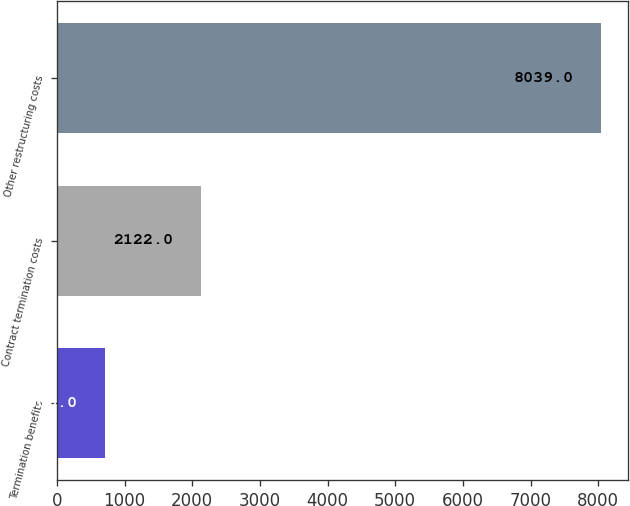Convert chart. <chart><loc_0><loc_0><loc_500><loc_500><bar_chart><fcel>Termination benefits<fcel>Contract termination costs<fcel>Other restructuring costs<nl><fcel>706<fcel>2122<fcel>8039<nl></chart> 